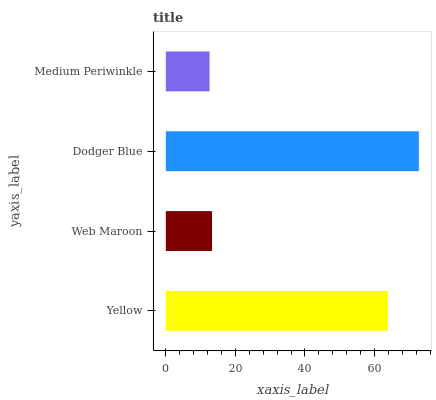Is Medium Periwinkle the minimum?
Answer yes or no. Yes. Is Dodger Blue the maximum?
Answer yes or no. Yes. Is Web Maroon the minimum?
Answer yes or no. No. Is Web Maroon the maximum?
Answer yes or no. No. Is Yellow greater than Web Maroon?
Answer yes or no. Yes. Is Web Maroon less than Yellow?
Answer yes or no. Yes. Is Web Maroon greater than Yellow?
Answer yes or no. No. Is Yellow less than Web Maroon?
Answer yes or no. No. Is Yellow the high median?
Answer yes or no. Yes. Is Web Maroon the low median?
Answer yes or no. Yes. Is Dodger Blue the high median?
Answer yes or no. No. Is Yellow the low median?
Answer yes or no. No. 